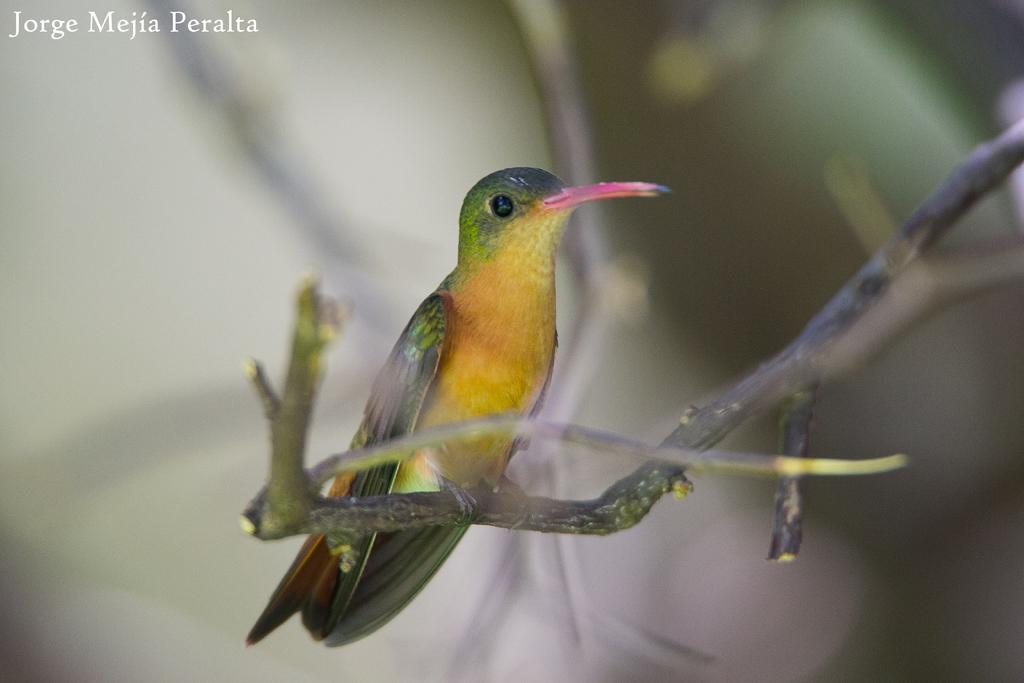What type of animal is present in the image? There is a bird in the image. Can you describe the bird's position or location in the image? The bird is on a stem. What type of jellyfish can be seen swimming in the image? There is no jellyfish present in the image; it features a bird on a stem. 